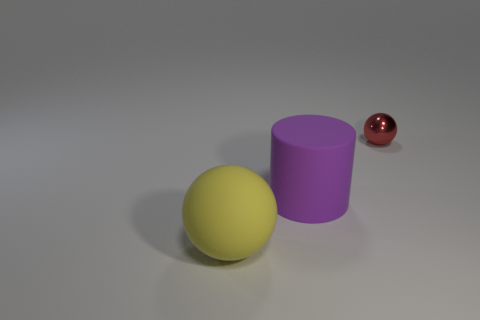Is there anything else that has the same shape as the purple matte object?
Give a very brief answer. No. What number of other objects are the same material as the small red ball?
Offer a terse response. 0. How many yellow things are rubber objects or matte cylinders?
Offer a very short reply. 1. There is a sphere in front of the red thing; what number of tiny metal balls are behind it?
Provide a succinct answer. 1. What number of other things are there of the same shape as the purple object?
Offer a very short reply. 0. There is a cylinder that is made of the same material as the yellow object; what color is it?
Keep it short and to the point. Purple. Are there any other purple matte cylinders that have the same size as the purple cylinder?
Give a very brief answer. No. Is the number of purple rubber objects behind the yellow matte object greater than the number of rubber things behind the tiny thing?
Your answer should be very brief. Yes. Does the sphere in front of the small red metallic thing have the same material as the ball that is behind the big purple rubber cylinder?
Provide a succinct answer. No. The yellow object that is the same size as the purple object is what shape?
Your response must be concise. Sphere. 